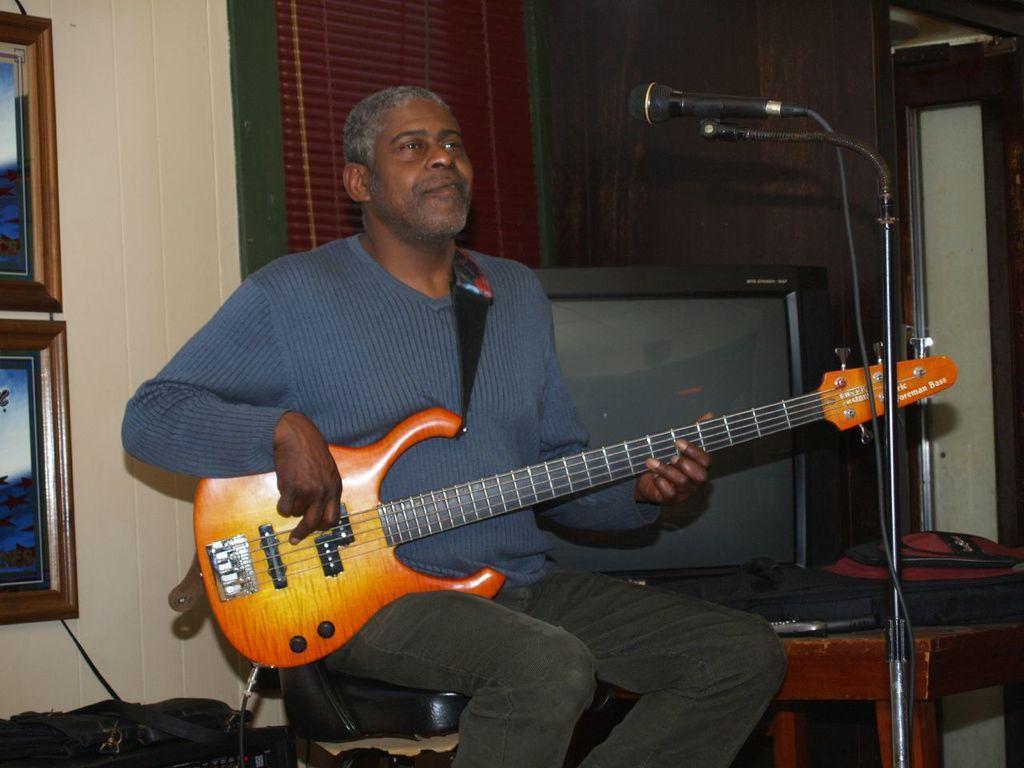Could you give a brief overview of what you see in this image? The image is inside the room. In the image there is a man sitting on chair and holding a guitar in front of a microphone. In background there is a wall which is in cream color and photo frames,window and television on table. 